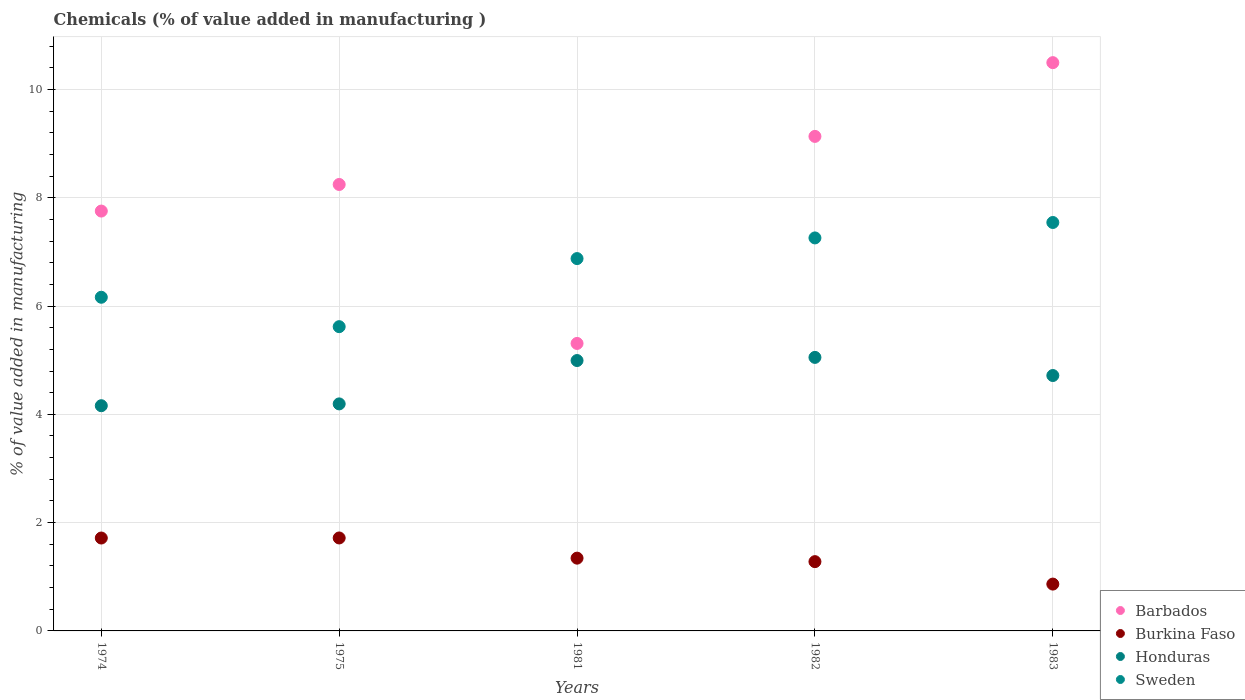Is the number of dotlines equal to the number of legend labels?
Make the answer very short. Yes. What is the value added in manufacturing chemicals in Burkina Faso in 1983?
Your answer should be compact. 0.86. Across all years, what is the maximum value added in manufacturing chemicals in Honduras?
Offer a very short reply. 5.05. Across all years, what is the minimum value added in manufacturing chemicals in Honduras?
Ensure brevity in your answer.  4.16. In which year was the value added in manufacturing chemicals in Barbados maximum?
Make the answer very short. 1983. In which year was the value added in manufacturing chemicals in Sweden minimum?
Provide a succinct answer. 1975. What is the total value added in manufacturing chemicals in Burkina Faso in the graph?
Ensure brevity in your answer.  6.92. What is the difference between the value added in manufacturing chemicals in Honduras in 1975 and that in 1983?
Ensure brevity in your answer.  -0.52. What is the difference between the value added in manufacturing chemicals in Sweden in 1983 and the value added in manufacturing chemicals in Honduras in 1981?
Offer a terse response. 2.55. What is the average value added in manufacturing chemicals in Barbados per year?
Provide a succinct answer. 8.19. In the year 1974, what is the difference between the value added in manufacturing chemicals in Burkina Faso and value added in manufacturing chemicals in Barbados?
Provide a short and direct response. -6.04. What is the ratio of the value added in manufacturing chemicals in Sweden in 1974 to that in 1983?
Offer a terse response. 0.82. What is the difference between the highest and the second highest value added in manufacturing chemicals in Sweden?
Offer a terse response. 0.28. What is the difference between the highest and the lowest value added in manufacturing chemicals in Sweden?
Provide a succinct answer. 1.92. In how many years, is the value added in manufacturing chemicals in Sweden greater than the average value added in manufacturing chemicals in Sweden taken over all years?
Your response must be concise. 3. Is it the case that in every year, the sum of the value added in manufacturing chemicals in Honduras and value added in manufacturing chemicals in Burkina Faso  is greater than the value added in manufacturing chemicals in Sweden?
Provide a succinct answer. No. Does the value added in manufacturing chemicals in Burkina Faso monotonically increase over the years?
Offer a very short reply. No. How many dotlines are there?
Make the answer very short. 4. Does the graph contain grids?
Your answer should be compact. Yes. Where does the legend appear in the graph?
Provide a succinct answer. Bottom right. How are the legend labels stacked?
Offer a very short reply. Vertical. What is the title of the graph?
Your answer should be compact. Chemicals (% of value added in manufacturing ). Does "Liechtenstein" appear as one of the legend labels in the graph?
Keep it short and to the point. No. What is the label or title of the X-axis?
Offer a very short reply. Years. What is the label or title of the Y-axis?
Your response must be concise. % of value added in manufacturing. What is the % of value added in manufacturing in Barbados in 1974?
Provide a short and direct response. 7.75. What is the % of value added in manufacturing in Burkina Faso in 1974?
Provide a short and direct response. 1.72. What is the % of value added in manufacturing in Honduras in 1974?
Give a very brief answer. 4.16. What is the % of value added in manufacturing in Sweden in 1974?
Give a very brief answer. 6.16. What is the % of value added in manufacturing in Barbados in 1975?
Offer a terse response. 8.24. What is the % of value added in manufacturing of Burkina Faso in 1975?
Provide a succinct answer. 1.72. What is the % of value added in manufacturing in Honduras in 1975?
Your answer should be very brief. 4.19. What is the % of value added in manufacturing of Sweden in 1975?
Provide a short and direct response. 5.62. What is the % of value added in manufacturing of Barbados in 1981?
Your answer should be compact. 5.31. What is the % of value added in manufacturing in Burkina Faso in 1981?
Give a very brief answer. 1.34. What is the % of value added in manufacturing in Honduras in 1981?
Offer a terse response. 4.99. What is the % of value added in manufacturing of Sweden in 1981?
Give a very brief answer. 6.88. What is the % of value added in manufacturing of Barbados in 1982?
Provide a short and direct response. 9.13. What is the % of value added in manufacturing in Burkina Faso in 1982?
Offer a very short reply. 1.28. What is the % of value added in manufacturing of Honduras in 1982?
Give a very brief answer. 5.05. What is the % of value added in manufacturing of Sweden in 1982?
Your answer should be very brief. 7.26. What is the % of value added in manufacturing of Barbados in 1983?
Provide a succinct answer. 10.5. What is the % of value added in manufacturing in Burkina Faso in 1983?
Offer a very short reply. 0.86. What is the % of value added in manufacturing of Honduras in 1983?
Provide a succinct answer. 4.72. What is the % of value added in manufacturing in Sweden in 1983?
Your response must be concise. 7.54. Across all years, what is the maximum % of value added in manufacturing in Barbados?
Your answer should be compact. 10.5. Across all years, what is the maximum % of value added in manufacturing of Burkina Faso?
Offer a terse response. 1.72. Across all years, what is the maximum % of value added in manufacturing in Honduras?
Give a very brief answer. 5.05. Across all years, what is the maximum % of value added in manufacturing of Sweden?
Your answer should be very brief. 7.54. Across all years, what is the minimum % of value added in manufacturing of Barbados?
Offer a terse response. 5.31. Across all years, what is the minimum % of value added in manufacturing in Burkina Faso?
Give a very brief answer. 0.86. Across all years, what is the minimum % of value added in manufacturing of Honduras?
Ensure brevity in your answer.  4.16. Across all years, what is the minimum % of value added in manufacturing of Sweden?
Make the answer very short. 5.62. What is the total % of value added in manufacturing in Barbados in the graph?
Offer a terse response. 40.94. What is the total % of value added in manufacturing in Burkina Faso in the graph?
Give a very brief answer. 6.92. What is the total % of value added in manufacturing of Honduras in the graph?
Your answer should be very brief. 23.11. What is the total % of value added in manufacturing of Sweden in the graph?
Your answer should be compact. 33.46. What is the difference between the % of value added in manufacturing in Barbados in 1974 and that in 1975?
Your answer should be very brief. -0.49. What is the difference between the % of value added in manufacturing of Burkina Faso in 1974 and that in 1975?
Provide a short and direct response. -0. What is the difference between the % of value added in manufacturing in Honduras in 1974 and that in 1975?
Provide a short and direct response. -0.03. What is the difference between the % of value added in manufacturing of Sweden in 1974 and that in 1975?
Your response must be concise. 0.54. What is the difference between the % of value added in manufacturing in Barbados in 1974 and that in 1981?
Provide a short and direct response. 2.44. What is the difference between the % of value added in manufacturing in Burkina Faso in 1974 and that in 1981?
Provide a succinct answer. 0.37. What is the difference between the % of value added in manufacturing of Honduras in 1974 and that in 1981?
Offer a terse response. -0.83. What is the difference between the % of value added in manufacturing in Sweden in 1974 and that in 1981?
Your answer should be very brief. -0.71. What is the difference between the % of value added in manufacturing of Barbados in 1974 and that in 1982?
Provide a succinct answer. -1.38. What is the difference between the % of value added in manufacturing in Burkina Faso in 1974 and that in 1982?
Your answer should be compact. 0.44. What is the difference between the % of value added in manufacturing of Honduras in 1974 and that in 1982?
Your answer should be very brief. -0.89. What is the difference between the % of value added in manufacturing in Sweden in 1974 and that in 1982?
Offer a very short reply. -1.1. What is the difference between the % of value added in manufacturing in Barbados in 1974 and that in 1983?
Offer a terse response. -2.74. What is the difference between the % of value added in manufacturing in Burkina Faso in 1974 and that in 1983?
Your answer should be very brief. 0.85. What is the difference between the % of value added in manufacturing of Honduras in 1974 and that in 1983?
Provide a short and direct response. -0.56. What is the difference between the % of value added in manufacturing of Sweden in 1974 and that in 1983?
Make the answer very short. -1.38. What is the difference between the % of value added in manufacturing in Barbados in 1975 and that in 1981?
Provide a short and direct response. 2.94. What is the difference between the % of value added in manufacturing of Burkina Faso in 1975 and that in 1981?
Your response must be concise. 0.37. What is the difference between the % of value added in manufacturing in Honduras in 1975 and that in 1981?
Give a very brief answer. -0.8. What is the difference between the % of value added in manufacturing in Sweden in 1975 and that in 1981?
Offer a very short reply. -1.26. What is the difference between the % of value added in manufacturing of Barbados in 1975 and that in 1982?
Offer a terse response. -0.89. What is the difference between the % of value added in manufacturing of Burkina Faso in 1975 and that in 1982?
Your response must be concise. 0.44. What is the difference between the % of value added in manufacturing in Honduras in 1975 and that in 1982?
Provide a short and direct response. -0.86. What is the difference between the % of value added in manufacturing in Sweden in 1975 and that in 1982?
Make the answer very short. -1.64. What is the difference between the % of value added in manufacturing in Barbados in 1975 and that in 1983?
Offer a very short reply. -2.25. What is the difference between the % of value added in manufacturing in Burkina Faso in 1975 and that in 1983?
Ensure brevity in your answer.  0.85. What is the difference between the % of value added in manufacturing of Honduras in 1975 and that in 1983?
Offer a very short reply. -0.52. What is the difference between the % of value added in manufacturing of Sweden in 1975 and that in 1983?
Make the answer very short. -1.92. What is the difference between the % of value added in manufacturing of Barbados in 1981 and that in 1982?
Your answer should be very brief. -3.82. What is the difference between the % of value added in manufacturing in Burkina Faso in 1981 and that in 1982?
Give a very brief answer. 0.06. What is the difference between the % of value added in manufacturing in Honduras in 1981 and that in 1982?
Offer a very short reply. -0.06. What is the difference between the % of value added in manufacturing of Sweden in 1981 and that in 1982?
Make the answer very short. -0.38. What is the difference between the % of value added in manufacturing in Barbados in 1981 and that in 1983?
Offer a terse response. -5.19. What is the difference between the % of value added in manufacturing of Burkina Faso in 1981 and that in 1983?
Offer a terse response. 0.48. What is the difference between the % of value added in manufacturing of Honduras in 1981 and that in 1983?
Ensure brevity in your answer.  0.28. What is the difference between the % of value added in manufacturing in Sweden in 1981 and that in 1983?
Give a very brief answer. -0.67. What is the difference between the % of value added in manufacturing in Barbados in 1982 and that in 1983?
Your answer should be very brief. -1.36. What is the difference between the % of value added in manufacturing of Burkina Faso in 1982 and that in 1983?
Make the answer very short. 0.41. What is the difference between the % of value added in manufacturing of Honduras in 1982 and that in 1983?
Your answer should be compact. 0.33. What is the difference between the % of value added in manufacturing in Sweden in 1982 and that in 1983?
Provide a short and direct response. -0.28. What is the difference between the % of value added in manufacturing in Barbados in 1974 and the % of value added in manufacturing in Burkina Faso in 1975?
Keep it short and to the point. 6.04. What is the difference between the % of value added in manufacturing in Barbados in 1974 and the % of value added in manufacturing in Honduras in 1975?
Keep it short and to the point. 3.56. What is the difference between the % of value added in manufacturing of Barbados in 1974 and the % of value added in manufacturing of Sweden in 1975?
Provide a succinct answer. 2.13. What is the difference between the % of value added in manufacturing of Burkina Faso in 1974 and the % of value added in manufacturing of Honduras in 1975?
Your answer should be compact. -2.48. What is the difference between the % of value added in manufacturing of Burkina Faso in 1974 and the % of value added in manufacturing of Sweden in 1975?
Offer a terse response. -3.9. What is the difference between the % of value added in manufacturing in Honduras in 1974 and the % of value added in manufacturing in Sweden in 1975?
Offer a terse response. -1.46. What is the difference between the % of value added in manufacturing of Barbados in 1974 and the % of value added in manufacturing of Burkina Faso in 1981?
Make the answer very short. 6.41. What is the difference between the % of value added in manufacturing in Barbados in 1974 and the % of value added in manufacturing in Honduras in 1981?
Your answer should be compact. 2.76. What is the difference between the % of value added in manufacturing in Barbados in 1974 and the % of value added in manufacturing in Sweden in 1981?
Ensure brevity in your answer.  0.88. What is the difference between the % of value added in manufacturing in Burkina Faso in 1974 and the % of value added in manufacturing in Honduras in 1981?
Provide a succinct answer. -3.28. What is the difference between the % of value added in manufacturing of Burkina Faso in 1974 and the % of value added in manufacturing of Sweden in 1981?
Make the answer very short. -5.16. What is the difference between the % of value added in manufacturing in Honduras in 1974 and the % of value added in manufacturing in Sweden in 1981?
Your response must be concise. -2.72. What is the difference between the % of value added in manufacturing in Barbados in 1974 and the % of value added in manufacturing in Burkina Faso in 1982?
Your answer should be very brief. 6.47. What is the difference between the % of value added in manufacturing in Barbados in 1974 and the % of value added in manufacturing in Honduras in 1982?
Offer a very short reply. 2.7. What is the difference between the % of value added in manufacturing of Barbados in 1974 and the % of value added in manufacturing of Sweden in 1982?
Provide a short and direct response. 0.5. What is the difference between the % of value added in manufacturing in Burkina Faso in 1974 and the % of value added in manufacturing in Honduras in 1982?
Offer a terse response. -3.34. What is the difference between the % of value added in manufacturing of Burkina Faso in 1974 and the % of value added in manufacturing of Sweden in 1982?
Ensure brevity in your answer.  -5.54. What is the difference between the % of value added in manufacturing of Honduras in 1974 and the % of value added in manufacturing of Sweden in 1982?
Provide a short and direct response. -3.1. What is the difference between the % of value added in manufacturing of Barbados in 1974 and the % of value added in manufacturing of Burkina Faso in 1983?
Provide a succinct answer. 6.89. What is the difference between the % of value added in manufacturing in Barbados in 1974 and the % of value added in manufacturing in Honduras in 1983?
Ensure brevity in your answer.  3.04. What is the difference between the % of value added in manufacturing in Barbados in 1974 and the % of value added in manufacturing in Sweden in 1983?
Make the answer very short. 0.21. What is the difference between the % of value added in manufacturing in Burkina Faso in 1974 and the % of value added in manufacturing in Honduras in 1983?
Ensure brevity in your answer.  -3. What is the difference between the % of value added in manufacturing in Burkina Faso in 1974 and the % of value added in manufacturing in Sweden in 1983?
Keep it short and to the point. -5.83. What is the difference between the % of value added in manufacturing of Honduras in 1974 and the % of value added in manufacturing of Sweden in 1983?
Make the answer very short. -3.38. What is the difference between the % of value added in manufacturing in Barbados in 1975 and the % of value added in manufacturing in Burkina Faso in 1981?
Ensure brevity in your answer.  6.9. What is the difference between the % of value added in manufacturing in Barbados in 1975 and the % of value added in manufacturing in Honduras in 1981?
Offer a terse response. 3.25. What is the difference between the % of value added in manufacturing of Barbados in 1975 and the % of value added in manufacturing of Sweden in 1981?
Offer a terse response. 1.37. What is the difference between the % of value added in manufacturing in Burkina Faso in 1975 and the % of value added in manufacturing in Honduras in 1981?
Keep it short and to the point. -3.28. What is the difference between the % of value added in manufacturing in Burkina Faso in 1975 and the % of value added in manufacturing in Sweden in 1981?
Give a very brief answer. -5.16. What is the difference between the % of value added in manufacturing in Honduras in 1975 and the % of value added in manufacturing in Sweden in 1981?
Give a very brief answer. -2.68. What is the difference between the % of value added in manufacturing in Barbados in 1975 and the % of value added in manufacturing in Burkina Faso in 1982?
Keep it short and to the point. 6.97. What is the difference between the % of value added in manufacturing of Barbados in 1975 and the % of value added in manufacturing of Honduras in 1982?
Your response must be concise. 3.19. What is the difference between the % of value added in manufacturing of Burkina Faso in 1975 and the % of value added in manufacturing of Honduras in 1982?
Offer a very short reply. -3.33. What is the difference between the % of value added in manufacturing in Burkina Faso in 1975 and the % of value added in manufacturing in Sweden in 1982?
Make the answer very short. -5.54. What is the difference between the % of value added in manufacturing in Honduras in 1975 and the % of value added in manufacturing in Sweden in 1982?
Your response must be concise. -3.07. What is the difference between the % of value added in manufacturing in Barbados in 1975 and the % of value added in manufacturing in Burkina Faso in 1983?
Provide a succinct answer. 7.38. What is the difference between the % of value added in manufacturing in Barbados in 1975 and the % of value added in manufacturing in Honduras in 1983?
Your answer should be compact. 3.53. What is the difference between the % of value added in manufacturing of Barbados in 1975 and the % of value added in manufacturing of Sweden in 1983?
Keep it short and to the point. 0.7. What is the difference between the % of value added in manufacturing of Burkina Faso in 1975 and the % of value added in manufacturing of Honduras in 1983?
Your answer should be very brief. -3. What is the difference between the % of value added in manufacturing of Burkina Faso in 1975 and the % of value added in manufacturing of Sweden in 1983?
Give a very brief answer. -5.83. What is the difference between the % of value added in manufacturing in Honduras in 1975 and the % of value added in manufacturing in Sweden in 1983?
Your answer should be very brief. -3.35. What is the difference between the % of value added in manufacturing of Barbados in 1981 and the % of value added in manufacturing of Burkina Faso in 1982?
Offer a very short reply. 4.03. What is the difference between the % of value added in manufacturing in Barbados in 1981 and the % of value added in manufacturing in Honduras in 1982?
Offer a very short reply. 0.26. What is the difference between the % of value added in manufacturing in Barbados in 1981 and the % of value added in manufacturing in Sweden in 1982?
Offer a terse response. -1.95. What is the difference between the % of value added in manufacturing of Burkina Faso in 1981 and the % of value added in manufacturing of Honduras in 1982?
Give a very brief answer. -3.71. What is the difference between the % of value added in manufacturing of Burkina Faso in 1981 and the % of value added in manufacturing of Sweden in 1982?
Your answer should be compact. -5.91. What is the difference between the % of value added in manufacturing of Honduras in 1981 and the % of value added in manufacturing of Sweden in 1982?
Offer a very short reply. -2.26. What is the difference between the % of value added in manufacturing of Barbados in 1981 and the % of value added in manufacturing of Burkina Faso in 1983?
Make the answer very short. 4.44. What is the difference between the % of value added in manufacturing in Barbados in 1981 and the % of value added in manufacturing in Honduras in 1983?
Give a very brief answer. 0.59. What is the difference between the % of value added in manufacturing in Barbados in 1981 and the % of value added in manufacturing in Sweden in 1983?
Provide a succinct answer. -2.23. What is the difference between the % of value added in manufacturing of Burkina Faso in 1981 and the % of value added in manufacturing of Honduras in 1983?
Offer a very short reply. -3.37. What is the difference between the % of value added in manufacturing of Burkina Faso in 1981 and the % of value added in manufacturing of Sweden in 1983?
Your response must be concise. -6.2. What is the difference between the % of value added in manufacturing in Honduras in 1981 and the % of value added in manufacturing in Sweden in 1983?
Provide a short and direct response. -2.55. What is the difference between the % of value added in manufacturing in Barbados in 1982 and the % of value added in manufacturing in Burkina Faso in 1983?
Ensure brevity in your answer.  8.27. What is the difference between the % of value added in manufacturing of Barbados in 1982 and the % of value added in manufacturing of Honduras in 1983?
Your answer should be very brief. 4.42. What is the difference between the % of value added in manufacturing of Barbados in 1982 and the % of value added in manufacturing of Sweden in 1983?
Offer a terse response. 1.59. What is the difference between the % of value added in manufacturing in Burkina Faso in 1982 and the % of value added in manufacturing in Honduras in 1983?
Make the answer very short. -3.44. What is the difference between the % of value added in manufacturing in Burkina Faso in 1982 and the % of value added in manufacturing in Sweden in 1983?
Keep it short and to the point. -6.26. What is the difference between the % of value added in manufacturing of Honduras in 1982 and the % of value added in manufacturing of Sweden in 1983?
Provide a succinct answer. -2.49. What is the average % of value added in manufacturing in Barbados per year?
Give a very brief answer. 8.19. What is the average % of value added in manufacturing of Burkina Faso per year?
Your answer should be very brief. 1.38. What is the average % of value added in manufacturing of Honduras per year?
Ensure brevity in your answer.  4.62. What is the average % of value added in manufacturing in Sweden per year?
Offer a terse response. 6.69. In the year 1974, what is the difference between the % of value added in manufacturing in Barbados and % of value added in manufacturing in Burkina Faso?
Offer a terse response. 6.04. In the year 1974, what is the difference between the % of value added in manufacturing in Barbados and % of value added in manufacturing in Honduras?
Your answer should be very brief. 3.59. In the year 1974, what is the difference between the % of value added in manufacturing of Barbados and % of value added in manufacturing of Sweden?
Give a very brief answer. 1.59. In the year 1974, what is the difference between the % of value added in manufacturing of Burkina Faso and % of value added in manufacturing of Honduras?
Offer a very short reply. -2.44. In the year 1974, what is the difference between the % of value added in manufacturing of Burkina Faso and % of value added in manufacturing of Sweden?
Offer a very short reply. -4.45. In the year 1974, what is the difference between the % of value added in manufacturing in Honduras and % of value added in manufacturing in Sweden?
Offer a very short reply. -2. In the year 1975, what is the difference between the % of value added in manufacturing of Barbados and % of value added in manufacturing of Burkina Faso?
Your answer should be compact. 6.53. In the year 1975, what is the difference between the % of value added in manufacturing of Barbados and % of value added in manufacturing of Honduras?
Offer a terse response. 4.05. In the year 1975, what is the difference between the % of value added in manufacturing of Barbados and % of value added in manufacturing of Sweden?
Your answer should be compact. 2.63. In the year 1975, what is the difference between the % of value added in manufacturing in Burkina Faso and % of value added in manufacturing in Honduras?
Offer a terse response. -2.48. In the year 1975, what is the difference between the % of value added in manufacturing in Burkina Faso and % of value added in manufacturing in Sweden?
Keep it short and to the point. -3.9. In the year 1975, what is the difference between the % of value added in manufacturing in Honduras and % of value added in manufacturing in Sweden?
Your answer should be very brief. -1.43. In the year 1981, what is the difference between the % of value added in manufacturing in Barbados and % of value added in manufacturing in Burkina Faso?
Your answer should be compact. 3.97. In the year 1981, what is the difference between the % of value added in manufacturing in Barbados and % of value added in manufacturing in Honduras?
Provide a succinct answer. 0.32. In the year 1981, what is the difference between the % of value added in manufacturing in Barbados and % of value added in manufacturing in Sweden?
Give a very brief answer. -1.57. In the year 1981, what is the difference between the % of value added in manufacturing in Burkina Faso and % of value added in manufacturing in Honduras?
Provide a short and direct response. -3.65. In the year 1981, what is the difference between the % of value added in manufacturing in Burkina Faso and % of value added in manufacturing in Sweden?
Make the answer very short. -5.53. In the year 1981, what is the difference between the % of value added in manufacturing in Honduras and % of value added in manufacturing in Sweden?
Offer a very short reply. -1.88. In the year 1982, what is the difference between the % of value added in manufacturing of Barbados and % of value added in manufacturing of Burkina Faso?
Ensure brevity in your answer.  7.85. In the year 1982, what is the difference between the % of value added in manufacturing in Barbados and % of value added in manufacturing in Honduras?
Keep it short and to the point. 4.08. In the year 1982, what is the difference between the % of value added in manufacturing of Barbados and % of value added in manufacturing of Sweden?
Offer a terse response. 1.88. In the year 1982, what is the difference between the % of value added in manufacturing of Burkina Faso and % of value added in manufacturing of Honduras?
Offer a terse response. -3.77. In the year 1982, what is the difference between the % of value added in manufacturing in Burkina Faso and % of value added in manufacturing in Sweden?
Ensure brevity in your answer.  -5.98. In the year 1982, what is the difference between the % of value added in manufacturing of Honduras and % of value added in manufacturing of Sweden?
Your response must be concise. -2.21. In the year 1983, what is the difference between the % of value added in manufacturing of Barbados and % of value added in manufacturing of Burkina Faso?
Provide a short and direct response. 9.63. In the year 1983, what is the difference between the % of value added in manufacturing of Barbados and % of value added in manufacturing of Honduras?
Offer a very short reply. 5.78. In the year 1983, what is the difference between the % of value added in manufacturing in Barbados and % of value added in manufacturing in Sweden?
Keep it short and to the point. 2.95. In the year 1983, what is the difference between the % of value added in manufacturing of Burkina Faso and % of value added in manufacturing of Honduras?
Ensure brevity in your answer.  -3.85. In the year 1983, what is the difference between the % of value added in manufacturing of Burkina Faso and % of value added in manufacturing of Sweden?
Provide a succinct answer. -6.68. In the year 1983, what is the difference between the % of value added in manufacturing of Honduras and % of value added in manufacturing of Sweden?
Ensure brevity in your answer.  -2.83. What is the ratio of the % of value added in manufacturing of Barbados in 1974 to that in 1975?
Make the answer very short. 0.94. What is the ratio of the % of value added in manufacturing of Burkina Faso in 1974 to that in 1975?
Your response must be concise. 1. What is the ratio of the % of value added in manufacturing in Sweden in 1974 to that in 1975?
Your answer should be very brief. 1.1. What is the ratio of the % of value added in manufacturing in Barbados in 1974 to that in 1981?
Your answer should be very brief. 1.46. What is the ratio of the % of value added in manufacturing in Burkina Faso in 1974 to that in 1981?
Your answer should be very brief. 1.28. What is the ratio of the % of value added in manufacturing of Honduras in 1974 to that in 1981?
Your answer should be compact. 0.83. What is the ratio of the % of value added in manufacturing of Sweden in 1974 to that in 1981?
Your answer should be very brief. 0.9. What is the ratio of the % of value added in manufacturing in Barbados in 1974 to that in 1982?
Provide a succinct answer. 0.85. What is the ratio of the % of value added in manufacturing in Burkina Faso in 1974 to that in 1982?
Your answer should be very brief. 1.34. What is the ratio of the % of value added in manufacturing in Honduras in 1974 to that in 1982?
Offer a terse response. 0.82. What is the ratio of the % of value added in manufacturing in Sweden in 1974 to that in 1982?
Your answer should be compact. 0.85. What is the ratio of the % of value added in manufacturing of Barbados in 1974 to that in 1983?
Keep it short and to the point. 0.74. What is the ratio of the % of value added in manufacturing in Burkina Faso in 1974 to that in 1983?
Your response must be concise. 1.98. What is the ratio of the % of value added in manufacturing in Honduras in 1974 to that in 1983?
Your answer should be very brief. 0.88. What is the ratio of the % of value added in manufacturing in Sweden in 1974 to that in 1983?
Ensure brevity in your answer.  0.82. What is the ratio of the % of value added in manufacturing in Barbados in 1975 to that in 1981?
Your response must be concise. 1.55. What is the ratio of the % of value added in manufacturing in Burkina Faso in 1975 to that in 1981?
Give a very brief answer. 1.28. What is the ratio of the % of value added in manufacturing in Honduras in 1975 to that in 1981?
Provide a short and direct response. 0.84. What is the ratio of the % of value added in manufacturing in Sweden in 1975 to that in 1981?
Provide a short and direct response. 0.82. What is the ratio of the % of value added in manufacturing of Barbados in 1975 to that in 1982?
Keep it short and to the point. 0.9. What is the ratio of the % of value added in manufacturing in Burkina Faso in 1975 to that in 1982?
Provide a succinct answer. 1.34. What is the ratio of the % of value added in manufacturing in Honduras in 1975 to that in 1982?
Keep it short and to the point. 0.83. What is the ratio of the % of value added in manufacturing of Sweden in 1975 to that in 1982?
Provide a short and direct response. 0.77. What is the ratio of the % of value added in manufacturing of Barbados in 1975 to that in 1983?
Ensure brevity in your answer.  0.79. What is the ratio of the % of value added in manufacturing in Burkina Faso in 1975 to that in 1983?
Provide a succinct answer. 1.98. What is the ratio of the % of value added in manufacturing of Sweden in 1975 to that in 1983?
Your response must be concise. 0.74. What is the ratio of the % of value added in manufacturing of Barbados in 1981 to that in 1982?
Offer a very short reply. 0.58. What is the ratio of the % of value added in manufacturing of Burkina Faso in 1981 to that in 1982?
Your response must be concise. 1.05. What is the ratio of the % of value added in manufacturing of Honduras in 1981 to that in 1982?
Offer a terse response. 0.99. What is the ratio of the % of value added in manufacturing in Sweden in 1981 to that in 1982?
Your response must be concise. 0.95. What is the ratio of the % of value added in manufacturing of Barbados in 1981 to that in 1983?
Make the answer very short. 0.51. What is the ratio of the % of value added in manufacturing in Burkina Faso in 1981 to that in 1983?
Your response must be concise. 1.55. What is the ratio of the % of value added in manufacturing in Honduras in 1981 to that in 1983?
Offer a very short reply. 1.06. What is the ratio of the % of value added in manufacturing in Sweden in 1981 to that in 1983?
Make the answer very short. 0.91. What is the ratio of the % of value added in manufacturing of Barbados in 1982 to that in 1983?
Give a very brief answer. 0.87. What is the ratio of the % of value added in manufacturing of Burkina Faso in 1982 to that in 1983?
Offer a terse response. 1.48. What is the ratio of the % of value added in manufacturing in Honduras in 1982 to that in 1983?
Ensure brevity in your answer.  1.07. What is the ratio of the % of value added in manufacturing in Sweden in 1982 to that in 1983?
Give a very brief answer. 0.96. What is the difference between the highest and the second highest % of value added in manufacturing of Barbados?
Provide a short and direct response. 1.36. What is the difference between the highest and the second highest % of value added in manufacturing in Burkina Faso?
Offer a very short reply. 0. What is the difference between the highest and the second highest % of value added in manufacturing in Honduras?
Give a very brief answer. 0.06. What is the difference between the highest and the second highest % of value added in manufacturing in Sweden?
Offer a terse response. 0.28. What is the difference between the highest and the lowest % of value added in manufacturing of Barbados?
Your answer should be compact. 5.19. What is the difference between the highest and the lowest % of value added in manufacturing of Burkina Faso?
Make the answer very short. 0.85. What is the difference between the highest and the lowest % of value added in manufacturing in Honduras?
Offer a terse response. 0.89. What is the difference between the highest and the lowest % of value added in manufacturing of Sweden?
Give a very brief answer. 1.92. 